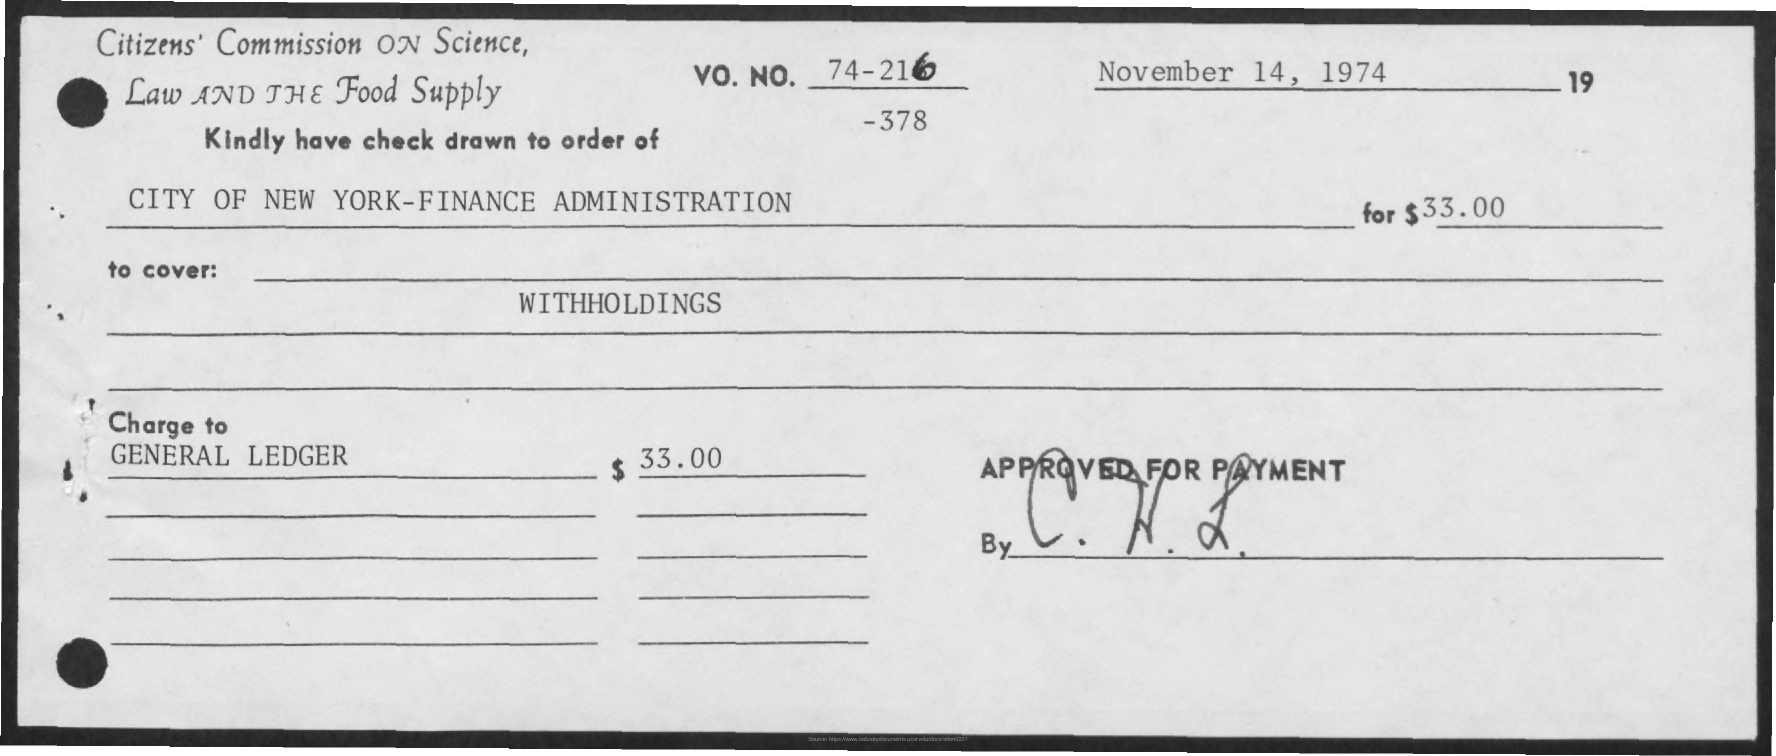How many dollars were written on the cheque? The cheque specifies an amount of $33.00, which is written both in numerical form and spelled out in text to confirm the payment amount. 